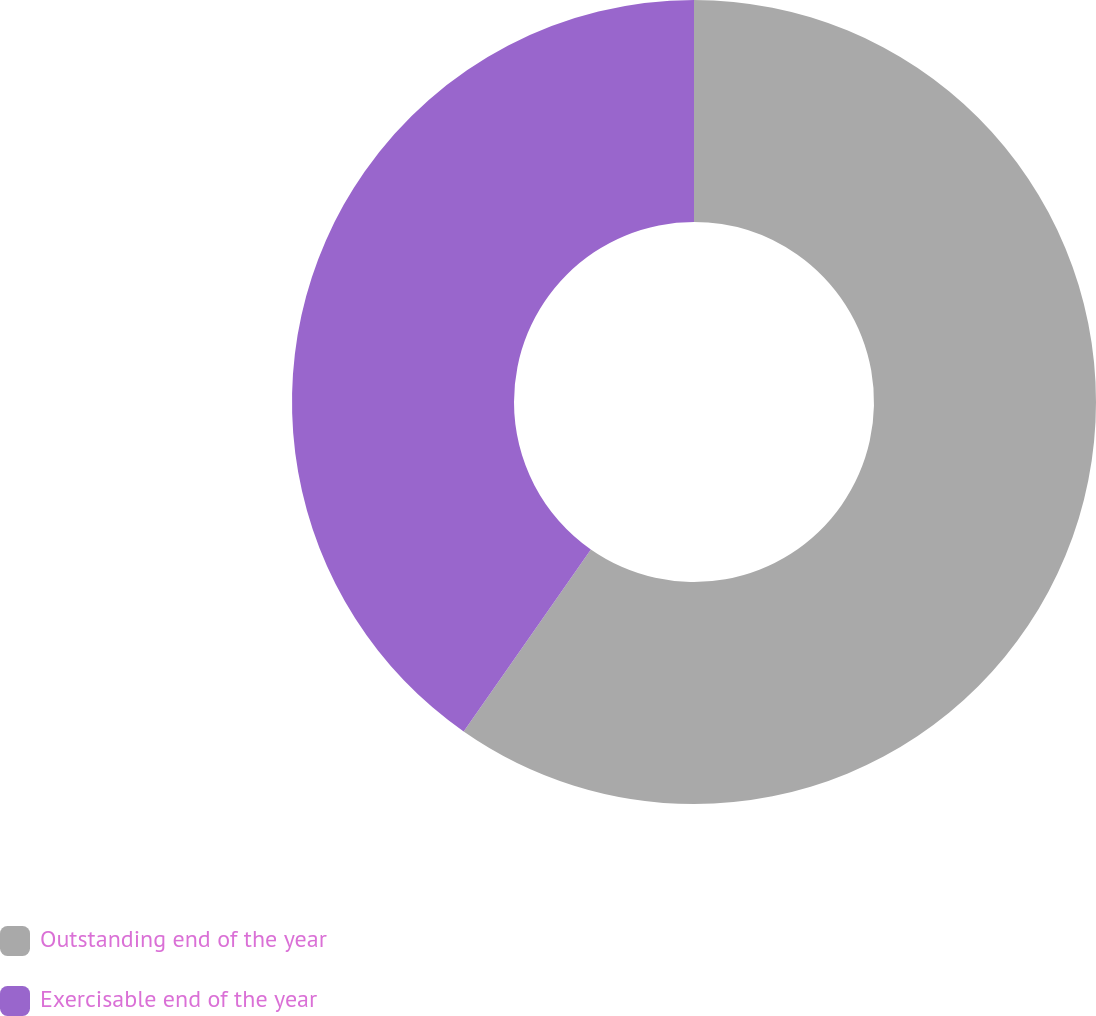<chart> <loc_0><loc_0><loc_500><loc_500><pie_chart><fcel>Outstanding end of the year<fcel>Exercisable end of the year<nl><fcel>59.71%<fcel>40.29%<nl></chart> 